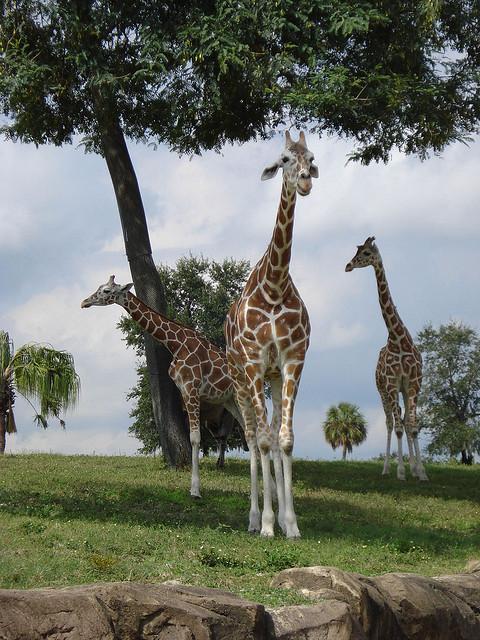How many giraffe  are there in the picture?
Give a very brief answer. 3. How many animals are shown?
Give a very brief answer. 3. How many giraffes are there?
Give a very brief answer. 3. How many people do you see wearing blue?
Give a very brief answer. 0. 